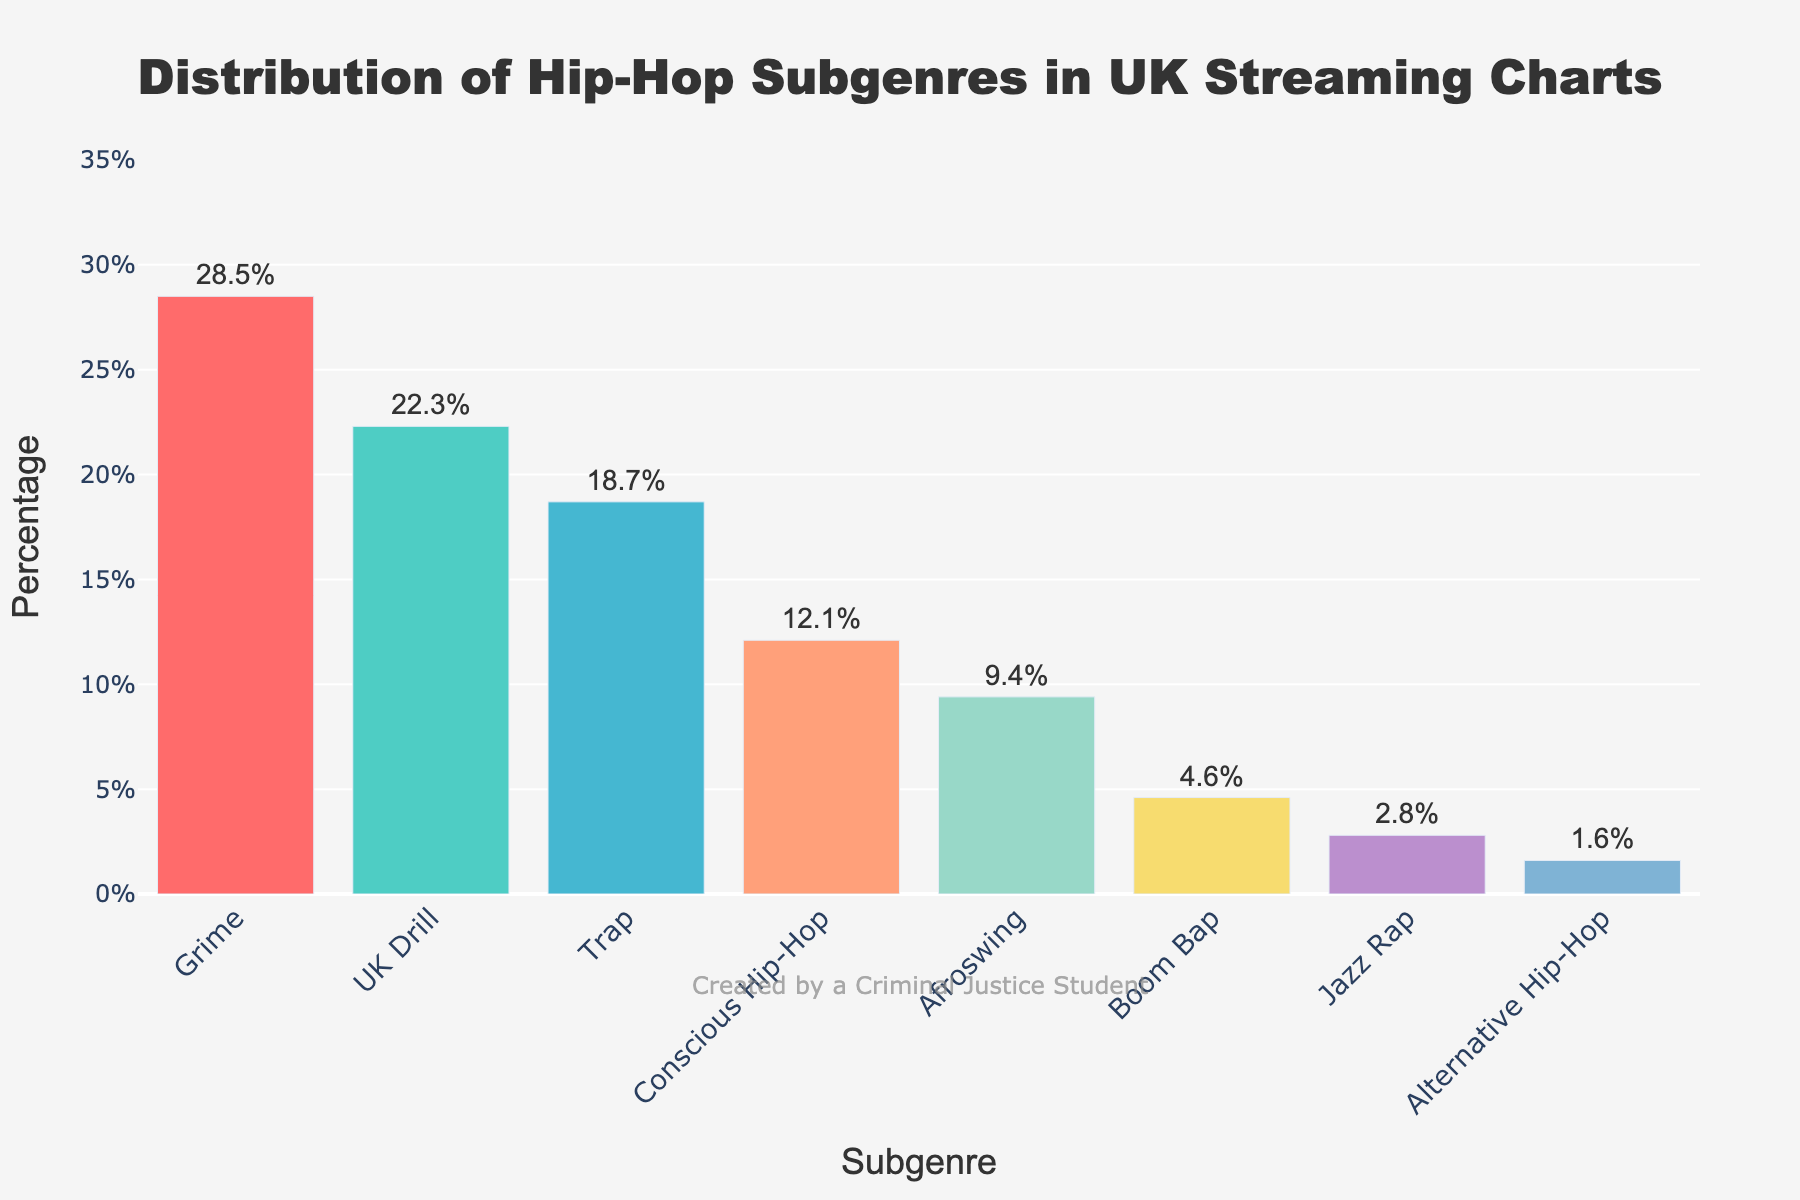What's the highest percentage of hip-hop subgenre in the UK streaming charts? The highest value on the y-axis represents the subgenre with the greatest percentage. "Grime" has the tallest bar reaching 28.5%.
Answer: 28.5% Which subgenre has the lowest percentage in the UK streaming charts? The shortest bar indicates the subgenre with the smallest percentage. "Alternative Hip-Hop" has a percentage of 1.6%.
Answer: Alternative Hip-Hop What is the difference in percentage between Grime and UK Drill? The percentage of Grime is 28.5%, and the percentage for UK Drill is 22.3%. Subtract 22.3 from 28.5 to get the difference: 28.5% - 22.3% = 6.2%.
Answer: 6.2% How much more popular is Trap compared to Boom Bap? The percentage for Trap is 18.7%, and for Boom Bap, it is 4.6%. The difference is 18.7% - 4.6% = 14.1%.
Answer: 14.1% Which subgenres have a combined percentage of over 50%? Adding the percentages of the top subgenres: Grime (28.5%) + UK Drill (22.3%) = 50.8%.
Answer: Grime and UK Drill What is the combined percentage of Conscious Hip-Hop, Afroswing, and Boom Bap? Adding the percentages of these subgenres: Conscious Hip-Hop (12.1%) + Afroswing (9.4%) + Boom Bap (4.6%) = 26.1%.
Answer: 26.1% Is Afroswing less or more popular compared to Conscious Hip-Hop? The percentage of Afroswing is 9.4%, and for Conscious Hip-Hop, it is 12.1%. Afroswing has a smaller percentage.
Answer: Less Which subgenre is represented by the red bar? The bar color 'red' corresponds to "Grime" which has the highest percentage of 28.5%.
Answer: Grime What is the average percentage of all subgenres combined? Sum all percentages and divide by the number of subgenres: (28.5% + 22.3% + 18.7% + 12.1% + 9.4% + 4.6% + 2.8% + 1.6%) / 8 = 100% / 8 = 12.5%.
Answer: 12.5% Does Jazz Rap have a higher percentage than Alternative Hip-Hop? Jazz Rap is at 2.8%, and Alternative Hip-Hop is at 1.6%. Jazz Rap has a higher percentage.
Answer: Yes 